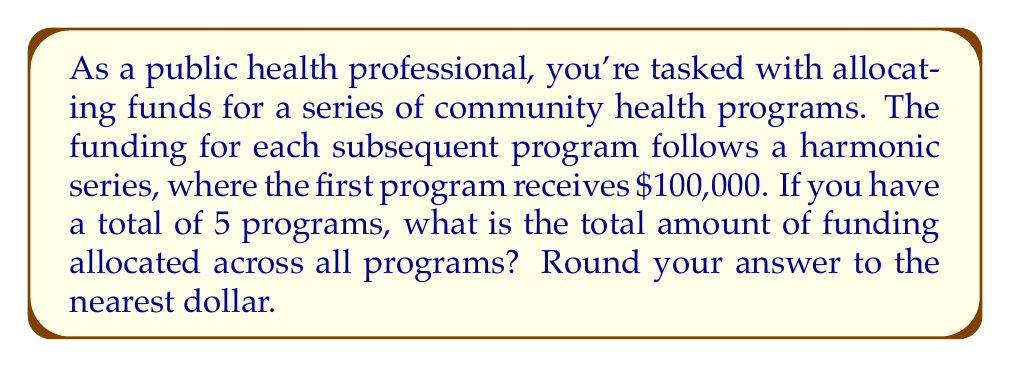What is the answer to this math problem? Let's approach this step-by-step:

1) The harmonic series is defined as: $\sum_{n=1}^{\infty} \frac{1}{n}$

2) In this case, we're using a finite harmonic series with 5 terms, and each term is multiplied by $100,000. So our series looks like this:

   $100,000 \cdot (1 + \frac{1}{2} + \frac{1}{3} + \frac{1}{4} + \frac{1}{5})$

3) Let's calculate the sum of the harmonic series first:

   $1 + \frac{1}{2} + \frac{1}{3} + \frac{1}{4} + \frac{1}{5} = 2.283333...$

4) Now, we multiply this by $100,000:

   $100,000 \cdot 2.283333... = 228,333.33...$

5) Rounding to the nearest dollar gives us $228,333.

Therefore, the total amount of funding allocated across all 5 programs is $228,333.
Answer: $228,333 